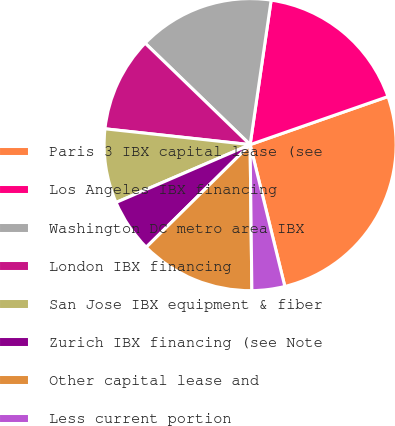Convert chart to OTSL. <chart><loc_0><loc_0><loc_500><loc_500><pie_chart><fcel>Paris 3 IBX capital lease (see<fcel>Los Angeles IBX financing<fcel>Washington DC metro area IBX<fcel>London IBX financing<fcel>San Jose IBX equipment & fiber<fcel>Zurich IBX financing (see Note<fcel>Other capital lease and<fcel>Less current portion<nl><fcel>26.52%<fcel>17.36%<fcel>15.07%<fcel>10.5%<fcel>8.21%<fcel>5.92%<fcel>12.79%<fcel>3.63%<nl></chart> 